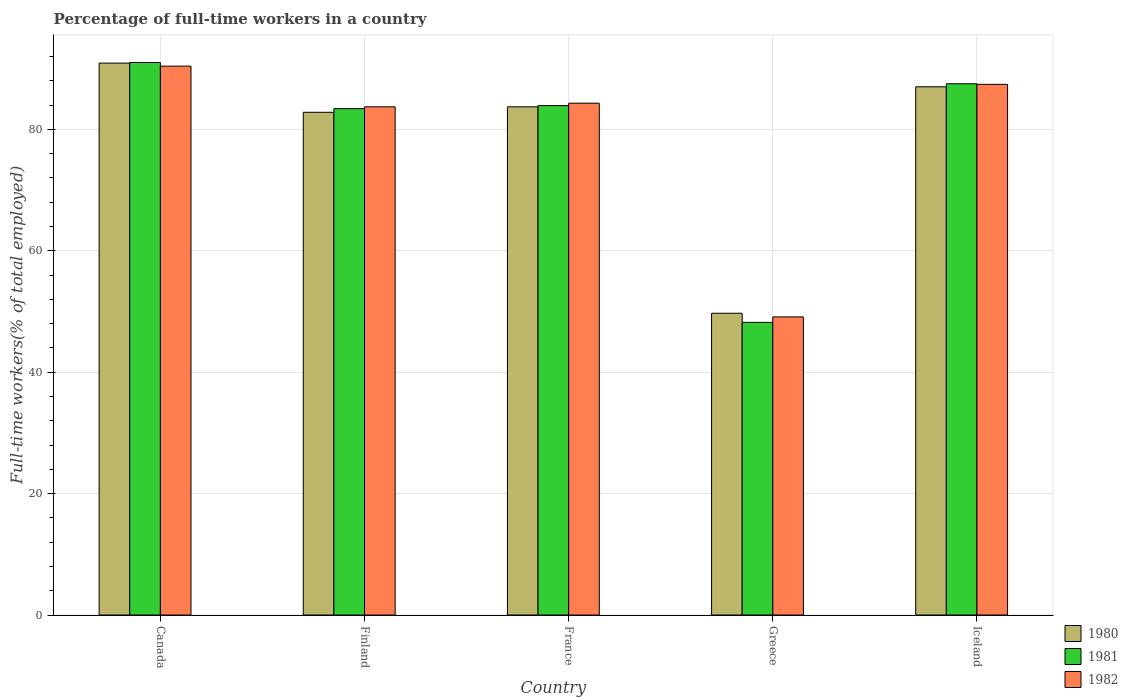Are the number of bars on each tick of the X-axis equal?
Offer a terse response. Yes. How many bars are there on the 2nd tick from the left?
Give a very brief answer. 3. What is the label of the 5th group of bars from the left?
Offer a very short reply. Iceland. In how many cases, is the number of bars for a given country not equal to the number of legend labels?
Make the answer very short. 0. What is the percentage of full-time workers in 1981 in Finland?
Ensure brevity in your answer.  83.4. Across all countries, what is the maximum percentage of full-time workers in 1981?
Keep it short and to the point. 91. Across all countries, what is the minimum percentage of full-time workers in 1981?
Offer a very short reply. 48.2. In which country was the percentage of full-time workers in 1980 maximum?
Offer a very short reply. Canada. In which country was the percentage of full-time workers in 1981 minimum?
Provide a succinct answer. Greece. What is the total percentage of full-time workers in 1980 in the graph?
Your answer should be very brief. 394.1. What is the difference between the percentage of full-time workers in 1982 in France and that in Iceland?
Provide a succinct answer. -3.1. What is the difference between the percentage of full-time workers in 1982 in Finland and the percentage of full-time workers in 1980 in Canada?
Ensure brevity in your answer.  -7.2. What is the average percentage of full-time workers in 1981 per country?
Give a very brief answer. 78.8. What is the difference between the percentage of full-time workers of/in 1981 and percentage of full-time workers of/in 1980 in Finland?
Make the answer very short. 0.6. In how many countries, is the percentage of full-time workers in 1982 greater than 84 %?
Your answer should be very brief. 3. What is the ratio of the percentage of full-time workers in 1982 in Canada to that in Greece?
Your answer should be very brief. 1.84. What is the difference between the highest and the second highest percentage of full-time workers in 1981?
Offer a terse response. -7.1. What is the difference between the highest and the lowest percentage of full-time workers in 1982?
Your answer should be very brief. 41.3. In how many countries, is the percentage of full-time workers in 1980 greater than the average percentage of full-time workers in 1980 taken over all countries?
Your response must be concise. 4. What does the 3rd bar from the left in Canada represents?
Your answer should be very brief. 1982. What does the 1st bar from the right in France represents?
Offer a very short reply. 1982. Is it the case that in every country, the sum of the percentage of full-time workers in 1980 and percentage of full-time workers in 1982 is greater than the percentage of full-time workers in 1981?
Offer a terse response. Yes. How many bars are there?
Keep it short and to the point. 15. Are all the bars in the graph horizontal?
Your answer should be very brief. No. What is the difference between two consecutive major ticks on the Y-axis?
Give a very brief answer. 20. Does the graph contain grids?
Provide a succinct answer. Yes. What is the title of the graph?
Provide a short and direct response. Percentage of full-time workers in a country. What is the label or title of the X-axis?
Offer a very short reply. Country. What is the label or title of the Y-axis?
Your answer should be very brief. Full-time workers(% of total employed). What is the Full-time workers(% of total employed) in 1980 in Canada?
Your answer should be compact. 90.9. What is the Full-time workers(% of total employed) in 1981 in Canada?
Ensure brevity in your answer.  91. What is the Full-time workers(% of total employed) of 1982 in Canada?
Provide a succinct answer. 90.4. What is the Full-time workers(% of total employed) in 1980 in Finland?
Your response must be concise. 82.8. What is the Full-time workers(% of total employed) of 1981 in Finland?
Make the answer very short. 83.4. What is the Full-time workers(% of total employed) of 1982 in Finland?
Make the answer very short. 83.7. What is the Full-time workers(% of total employed) of 1980 in France?
Make the answer very short. 83.7. What is the Full-time workers(% of total employed) of 1981 in France?
Make the answer very short. 83.9. What is the Full-time workers(% of total employed) in 1982 in France?
Your response must be concise. 84.3. What is the Full-time workers(% of total employed) in 1980 in Greece?
Keep it short and to the point. 49.7. What is the Full-time workers(% of total employed) of 1981 in Greece?
Provide a short and direct response. 48.2. What is the Full-time workers(% of total employed) in 1982 in Greece?
Provide a succinct answer. 49.1. What is the Full-time workers(% of total employed) in 1981 in Iceland?
Keep it short and to the point. 87.5. What is the Full-time workers(% of total employed) of 1982 in Iceland?
Keep it short and to the point. 87.4. Across all countries, what is the maximum Full-time workers(% of total employed) in 1980?
Offer a very short reply. 90.9. Across all countries, what is the maximum Full-time workers(% of total employed) of 1981?
Your answer should be very brief. 91. Across all countries, what is the maximum Full-time workers(% of total employed) of 1982?
Provide a succinct answer. 90.4. Across all countries, what is the minimum Full-time workers(% of total employed) in 1980?
Provide a succinct answer. 49.7. Across all countries, what is the minimum Full-time workers(% of total employed) of 1981?
Your answer should be very brief. 48.2. Across all countries, what is the minimum Full-time workers(% of total employed) of 1982?
Your answer should be compact. 49.1. What is the total Full-time workers(% of total employed) in 1980 in the graph?
Offer a terse response. 394.1. What is the total Full-time workers(% of total employed) in 1981 in the graph?
Offer a terse response. 394. What is the total Full-time workers(% of total employed) in 1982 in the graph?
Offer a terse response. 394.9. What is the difference between the Full-time workers(% of total employed) in 1981 in Canada and that in Finland?
Keep it short and to the point. 7.6. What is the difference between the Full-time workers(% of total employed) of 1982 in Canada and that in Finland?
Offer a very short reply. 6.7. What is the difference between the Full-time workers(% of total employed) of 1980 in Canada and that in France?
Your answer should be compact. 7.2. What is the difference between the Full-time workers(% of total employed) in 1981 in Canada and that in France?
Offer a terse response. 7.1. What is the difference between the Full-time workers(% of total employed) in 1982 in Canada and that in France?
Give a very brief answer. 6.1. What is the difference between the Full-time workers(% of total employed) of 1980 in Canada and that in Greece?
Your answer should be compact. 41.2. What is the difference between the Full-time workers(% of total employed) of 1981 in Canada and that in Greece?
Your response must be concise. 42.8. What is the difference between the Full-time workers(% of total employed) in 1982 in Canada and that in Greece?
Offer a very short reply. 41.3. What is the difference between the Full-time workers(% of total employed) in 1980 in Canada and that in Iceland?
Keep it short and to the point. 3.9. What is the difference between the Full-time workers(% of total employed) in 1981 in Canada and that in Iceland?
Provide a short and direct response. 3.5. What is the difference between the Full-time workers(% of total employed) in 1981 in Finland and that in France?
Keep it short and to the point. -0.5. What is the difference between the Full-time workers(% of total employed) of 1980 in Finland and that in Greece?
Ensure brevity in your answer.  33.1. What is the difference between the Full-time workers(% of total employed) in 1981 in Finland and that in Greece?
Keep it short and to the point. 35.2. What is the difference between the Full-time workers(% of total employed) of 1982 in Finland and that in Greece?
Your answer should be compact. 34.6. What is the difference between the Full-time workers(% of total employed) in 1981 in France and that in Greece?
Keep it short and to the point. 35.7. What is the difference between the Full-time workers(% of total employed) of 1982 in France and that in Greece?
Give a very brief answer. 35.2. What is the difference between the Full-time workers(% of total employed) in 1980 in France and that in Iceland?
Offer a terse response. -3.3. What is the difference between the Full-time workers(% of total employed) in 1981 in France and that in Iceland?
Your answer should be very brief. -3.6. What is the difference between the Full-time workers(% of total employed) in 1982 in France and that in Iceland?
Your answer should be compact. -3.1. What is the difference between the Full-time workers(% of total employed) in 1980 in Greece and that in Iceland?
Keep it short and to the point. -37.3. What is the difference between the Full-time workers(% of total employed) in 1981 in Greece and that in Iceland?
Give a very brief answer. -39.3. What is the difference between the Full-time workers(% of total employed) of 1982 in Greece and that in Iceland?
Make the answer very short. -38.3. What is the difference between the Full-time workers(% of total employed) in 1980 in Canada and the Full-time workers(% of total employed) in 1981 in Finland?
Your answer should be compact. 7.5. What is the difference between the Full-time workers(% of total employed) of 1981 in Canada and the Full-time workers(% of total employed) of 1982 in Finland?
Keep it short and to the point. 7.3. What is the difference between the Full-time workers(% of total employed) in 1980 in Canada and the Full-time workers(% of total employed) in 1982 in France?
Your response must be concise. 6.6. What is the difference between the Full-time workers(% of total employed) in 1981 in Canada and the Full-time workers(% of total employed) in 1982 in France?
Make the answer very short. 6.7. What is the difference between the Full-time workers(% of total employed) of 1980 in Canada and the Full-time workers(% of total employed) of 1981 in Greece?
Offer a terse response. 42.7. What is the difference between the Full-time workers(% of total employed) in 1980 in Canada and the Full-time workers(% of total employed) in 1982 in Greece?
Keep it short and to the point. 41.8. What is the difference between the Full-time workers(% of total employed) in 1981 in Canada and the Full-time workers(% of total employed) in 1982 in Greece?
Provide a succinct answer. 41.9. What is the difference between the Full-time workers(% of total employed) of 1980 in Canada and the Full-time workers(% of total employed) of 1981 in Iceland?
Ensure brevity in your answer.  3.4. What is the difference between the Full-time workers(% of total employed) in 1980 in Canada and the Full-time workers(% of total employed) in 1982 in Iceland?
Make the answer very short. 3.5. What is the difference between the Full-time workers(% of total employed) of 1981 in Canada and the Full-time workers(% of total employed) of 1982 in Iceland?
Offer a terse response. 3.6. What is the difference between the Full-time workers(% of total employed) of 1980 in Finland and the Full-time workers(% of total employed) of 1981 in France?
Provide a succinct answer. -1.1. What is the difference between the Full-time workers(% of total employed) of 1980 in Finland and the Full-time workers(% of total employed) of 1982 in France?
Your answer should be compact. -1.5. What is the difference between the Full-time workers(% of total employed) in 1981 in Finland and the Full-time workers(% of total employed) in 1982 in France?
Offer a terse response. -0.9. What is the difference between the Full-time workers(% of total employed) in 1980 in Finland and the Full-time workers(% of total employed) in 1981 in Greece?
Your answer should be very brief. 34.6. What is the difference between the Full-time workers(% of total employed) in 1980 in Finland and the Full-time workers(% of total employed) in 1982 in Greece?
Give a very brief answer. 33.7. What is the difference between the Full-time workers(% of total employed) of 1981 in Finland and the Full-time workers(% of total employed) of 1982 in Greece?
Make the answer very short. 34.3. What is the difference between the Full-time workers(% of total employed) of 1981 in Finland and the Full-time workers(% of total employed) of 1982 in Iceland?
Make the answer very short. -4. What is the difference between the Full-time workers(% of total employed) of 1980 in France and the Full-time workers(% of total employed) of 1981 in Greece?
Your response must be concise. 35.5. What is the difference between the Full-time workers(% of total employed) in 1980 in France and the Full-time workers(% of total employed) in 1982 in Greece?
Make the answer very short. 34.6. What is the difference between the Full-time workers(% of total employed) of 1981 in France and the Full-time workers(% of total employed) of 1982 in Greece?
Your answer should be compact. 34.8. What is the difference between the Full-time workers(% of total employed) of 1980 in France and the Full-time workers(% of total employed) of 1982 in Iceland?
Provide a short and direct response. -3.7. What is the difference between the Full-time workers(% of total employed) in 1980 in Greece and the Full-time workers(% of total employed) in 1981 in Iceland?
Your answer should be very brief. -37.8. What is the difference between the Full-time workers(% of total employed) of 1980 in Greece and the Full-time workers(% of total employed) of 1982 in Iceland?
Ensure brevity in your answer.  -37.7. What is the difference between the Full-time workers(% of total employed) of 1981 in Greece and the Full-time workers(% of total employed) of 1982 in Iceland?
Ensure brevity in your answer.  -39.2. What is the average Full-time workers(% of total employed) in 1980 per country?
Make the answer very short. 78.82. What is the average Full-time workers(% of total employed) in 1981 per country?
Provide a succinct answer. 78.8. What is the average Full-time workers(% of total employed) in 1982 per country?
Provide a succinct answer. 78.98. What is the difference between the Full-time workers(% of total employed) of 1980 and Full-time workers(% of total employed) of 1981 in Canada?
Offer a terse response. -0.1. What is the difference between the Full-time workers(% of total employed) in 1980 and Full-time workers(% of total employed) in 1981 in Finland?
Give a very brief answer. -0.6. What is the difference between the Full-time workers(% of total employed) of 1980 and Full-time workers(% of total employed) of 1981 in France?
Offer a terse response. -0.2. What is the difference between the Full-time workers(% of total employed) in 1980 and Full-time workers(% of total employed) in 1982 in France?
Keep it short and to the point. -0.6. What is the difference between the Full-time workers(% of total employed) of 1980 and Full-time workers(% of total employed) of 1982 in Greece?
Provide a short and direct response. 0.6. What is the difference between the Full-time workers(% of total employed) of 1981 and Full-time workers(% of total employed) of 1982 in Greece?
Give a very brief answer. -0.9. What is the difference between the Full-time workers(% of total employed) in 1981 and Full-time workers(% of total employed) in 1982 in Iceland?
Your response must be concise. 0.1. What is the ratio of the Full-time workers(% of total employed) in 1980 in Canada to that in Finland?
Ensure brevity in your answer.  1.1. What is the ratio of the Full-time workers(% of total employed) in 1981 in Canada to that in Finland?
Your answer should be very brief. 1.09. What is the ratio of the Full-time workers(% of total employed) of 1980 in Canada to that in France?
Your answer should be compact. 1.09. What is the ratio of the Full-time workers(% of total employed) of 1981 in Canada to that in France?
Your answer should be very brief. 1.08. What is the ratio of the Full-time workers(% of total employed) in 1982 in Canada to that in France?
Keep it short and to the point. 1.07. What is the ratio of the Full-time workers(% of total employed) of 1980 in Canada to that in Greece?
Provide a succinct answer. 1.83. What is the ratio of the Full-time workers(% of total employed) of 1981 in Canada to that in Greece?
Your answer should be compact. 1.89. What is the ratio of the Full-time workers(% of total employed) of 1982 in Canada to that in Greece?
Your answer should be very brief. 1.84. What is the ratio of the Full-time workers(% of total employed) in 1980 in Canada to that in Iceland?
Offer a terse response. 1.04. What is the ratio of the Full-time workers(% of total employed) in 1981 in Canada to that in Iceland?
Ensure brevity in your answer.  1.04. What is the ratio of the Full-time workers(% of total employed) in 1982 in Canada to that in Iceland?
Give a very brief answer. 1.03. What is the ratio of the Full-time workers(% of total employed) in 1982 in Finland to that in France?
Provide a short and direct response. 0.99. What is the ratio of the Full-time workers(% of total employed) of 1980 in Finland to that in Greece?
Your answer should be very brief. 1.67. What is the ratio of the Full-time workers(% of total employed) in 1981 in Finland to that in Greece?
Your response must be concise. 1.73. What is the ratio of the Full-time workers(% of total employed) in 1982 in Finland to that in Greece?
Keep it short and to the point. 1.7. What is the ratio of the Full-time workers(% of total employed) in 1980 in Finland to that in Iceland?
Ensure brevity in your answer.  0.95. What is the ratio of the Full-time workers(% of total employed) in 1981 in Finland to that in Iceland?
Keep it short and to the point. 0.95. What is the ratio of the Full-time workers(% of total employed) in 1982 in Finland to that in Iceland?
Your answer should be compact. 0.96. What is the ratio of the Full-time workers(% of total employed) in 1980 in France to that in Greece?
Your response must be concise. 1.68. What is the ratio of the Full-time workers(% of total employed) of 1981 in France to that in Greece?
Provide a short and direct response. 1.74. What is the ratio of the Full-time workers(% of total employed) in 1982 in France to that in Greece?
Provide a succinct answer. 1.72. What is the ratio of the Full-time workers(% of total employed) in 1980 in France to that in Iceland?
Offer a terse response. 0.96. What is the ratio of the Full-time workers(% of total employed) in 1981 in France to that in Iceland?
Provide a short and direct response. 0.96. What is the ratio of the Full-time workers(% of total employed) of 1982 in France to that in Iceland?
Your answer should be very brief. 0.96. What is the ratio of the Full-time workers(% of total employed) in 1980 in Greece to that in Iceland?
Provide a short and direct response. 0.57. What is the ratio of the Full-time workers(% of total employed) in 1981 in Greece to that in Iceland?
Ensure brevity in your answer.  0.55. What is the ratio of the Full-time workers(% of total employed) in 1982 in Greece to that in Iceland?
Your answer should be compact. 0.56. What is the difference between the highest and the second highest Full-time workers(% of total employed) in 1980?
Offer a terse response. 3.9. What is the difference between the highest and the second highest Full-time workers(% of total employed) in 1981?
Provide a succinct answer. 3.5. What is the difference between the highest and the lowest Full-time workers(% of total employed) of 1980?
Give a very brief answer. 41.2. What is the difference between the highest and the lowest Full-time workers(% of total employed) in 1981?
Give a very brief answer. 42.8. What is the difference between the highest and the lowest Full-time workers(% of total employed) in 1982?
Ensure brevity in your answer.  41.3. 